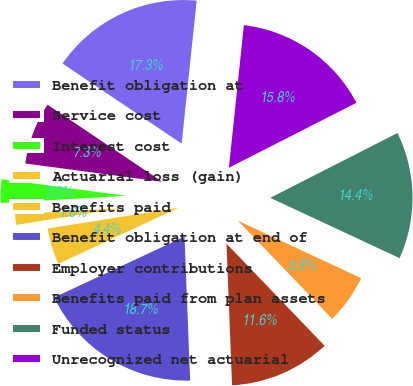Convert chart to OTSL. <chart><loc_0><loc_0><loc_500><loc_500><pie_chart><fcel>Benefit obligation at<fcel>Service cost<fcel>Interest cost<fcel>Actuarial loss (gain)<fcel>Benefits paid<fcel>Benefit obligation at end of<fcel>Employer contributions<fcel>Benefits paid from plan assets<fcel>Funded status<fcel>Unrecognized net actuarial<nl><fcel>17.27%<fcel>7.29%<fcel>3.02%<fcel>1.59%<fcel>4.44%<fcel>18.69%<fcel>11.57%<fcel>5.87%<fcel>14.42%<fcel>15.84%<nl></chart> 